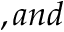Convert formula to latex. <formula><loc_0><loc_0><loc_500><loc_500>, a n d</formula> 